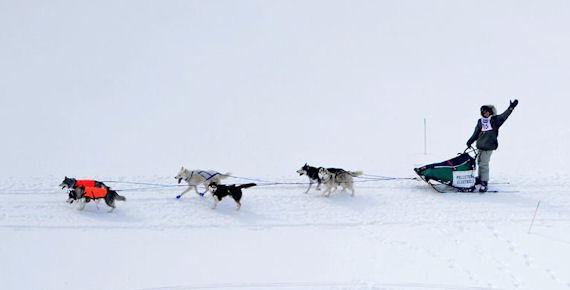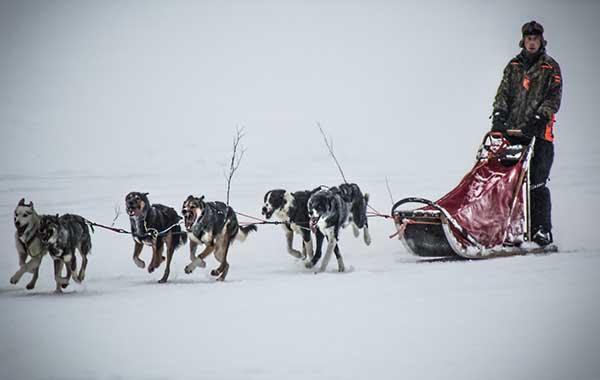The first image is the image on the left, the second image is the image on the right. Considering the images on both sides, is "Right image shows a dog team heading rightward, with the sled and driver visible behind it." valid? Answer yes or no. Yes. The first image is the image on the left, the second image is the image on the right. Given the left and right images, does the statement "There are no trees behind the dogs in at least one of the images." hold true? Answer yes or no. Yes. 